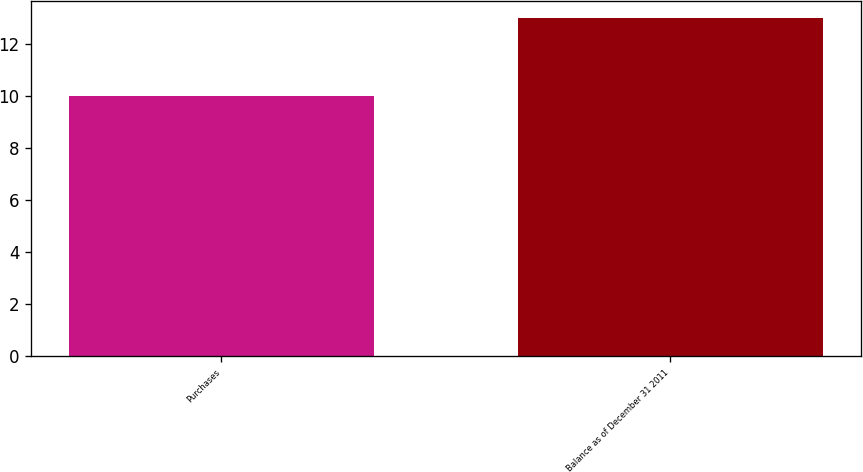Convert chart. <chart><loc_0><loc_0><loc_500><loc_500><bar_chart><fcel>Purchases<fcel>Balance as of December 31 2011<nl><fcel>10<fcel>13<nl></chart> 